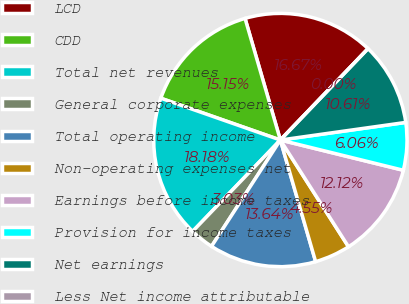<chart> <loc_0><loc_0><loc_500><loc_500><pie_chart><fcel>LCD<fcel>CDD<fcel>Total net revenues<fcel>General corporate expenses<fcel>Total operating income<fcel>Non-operating expenses net<fcel>Earnings before income taxes<fcel>Provision for income taxes<fcel>Net earnings<fcel>Less Net income attributable<nl><fcel>16.67%<fcel>15.15%<fcel>18.18%<fcel>3.03%<fcel>13.64%<fcel>4.55%<fcel>12.12%<fcel>6.06%<fcel>10.61%<fcel>0.0%<nl></chart> 